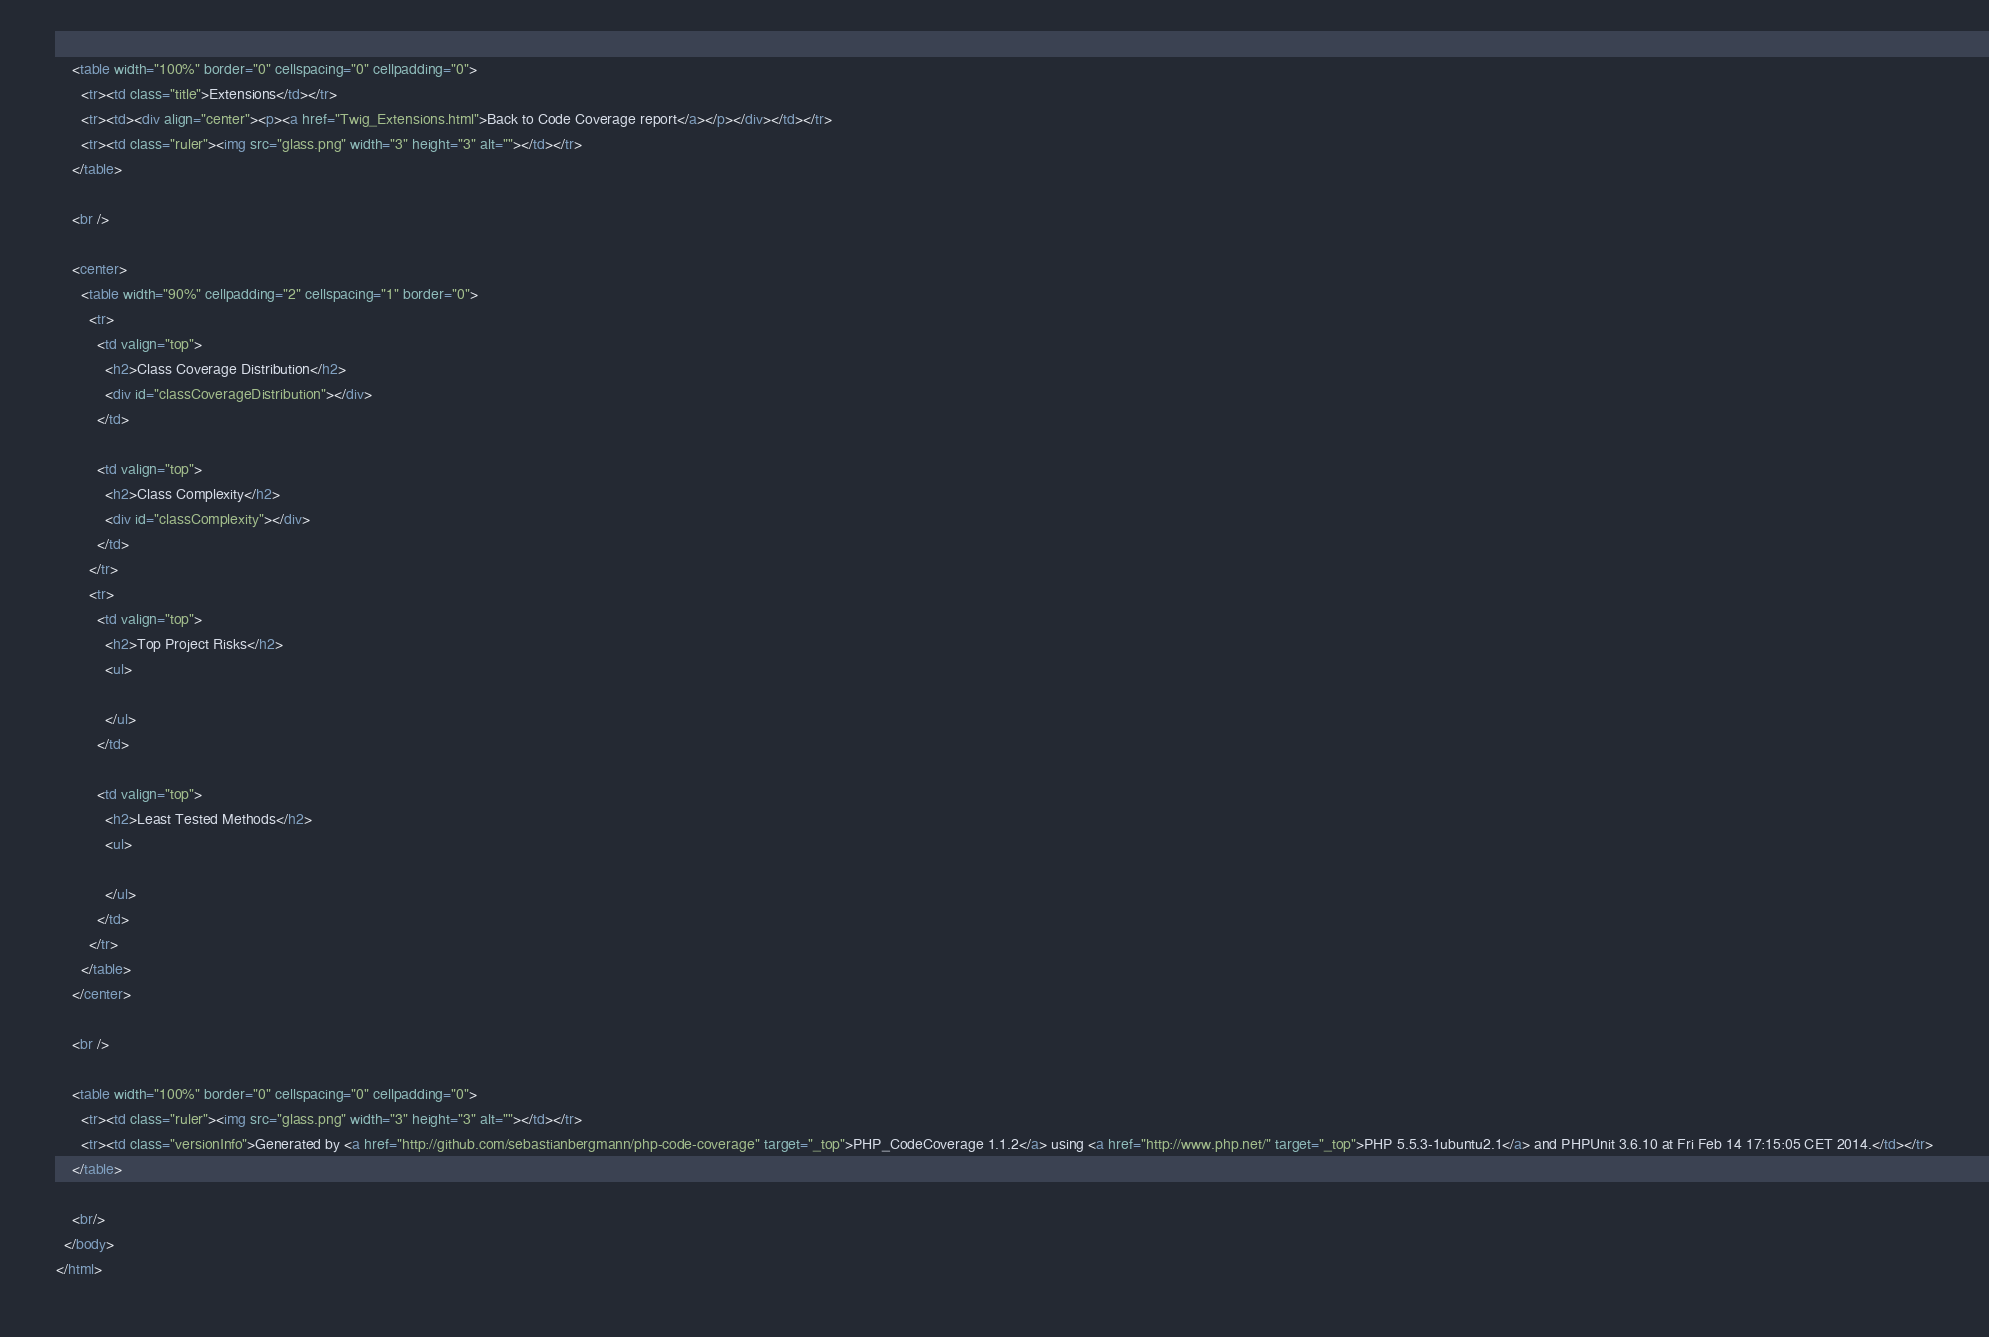<code> <loc_0><loc_0><loc_500><loc_500><_HTML_>    <table width="100%" border="0" cellspacing="0" cellpadding="0">
      <tr><td class="title">Extensions</td></tr>
      <tr><td><div align="center"><p><a href="Twig_Extensions.html">Back to Code Coverage report</a></p></div></td></tr>
      <tr><td class="ruler"><img src="glass.png" width="3" height="3" alt=""></td></tr>
    </table>

    <br />

    <center>
      <table width="90%" cellpadding="2" cellspacing="1" border="0">
        <tr>
          <td valign="top">
            <h2>Class Coverage Distribution</h2>
            <div id="classCoverageDistribution"></div>
          </td>

          <td valign="top">
            <h2>Class Complexity</h2>
            <div id="classComplexity"></div>
          </td>
        </tr>
        <tr>
          <td valign="top">
            <h2>Top Project Risks</h2>
            <ul>

            </ul>
          </td>

          <td valign="top">
            <h2>Least Tested Methods</h2>
            <ul>

            </ul>
          </td>
        </tr>
      </table>
    </center>

    <br />

    <table width="100%" border="0" cellspacing="0" cellpadding="0">
      <tr><td class="ruler"><img src="glass.png" width="3" height="3" alt=""></td></tr>
      <tr><td class="versionInfo">Generated by <a href="http://github.com/sebastianbergmann/php-code-coverage" target="_top">PHP_CodeCoverage 1.1.2</a> using <a href="http://www.php.net/" target="_top">PHP 5.5.3-1ubuntu2.1</a> and PHPUnit 3.6.10 at Fri Feb 14 17:15:05 CET 2014.</td></tr>
    </table>

    <br/>
  </body>
</html>
</code> 